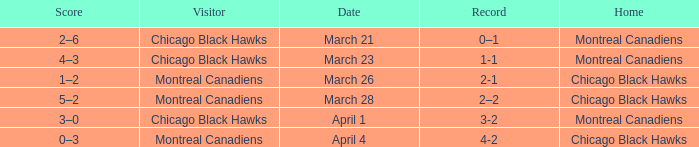Which team, playing at home, holds a 3-2 score? Montreal Canadiens. 